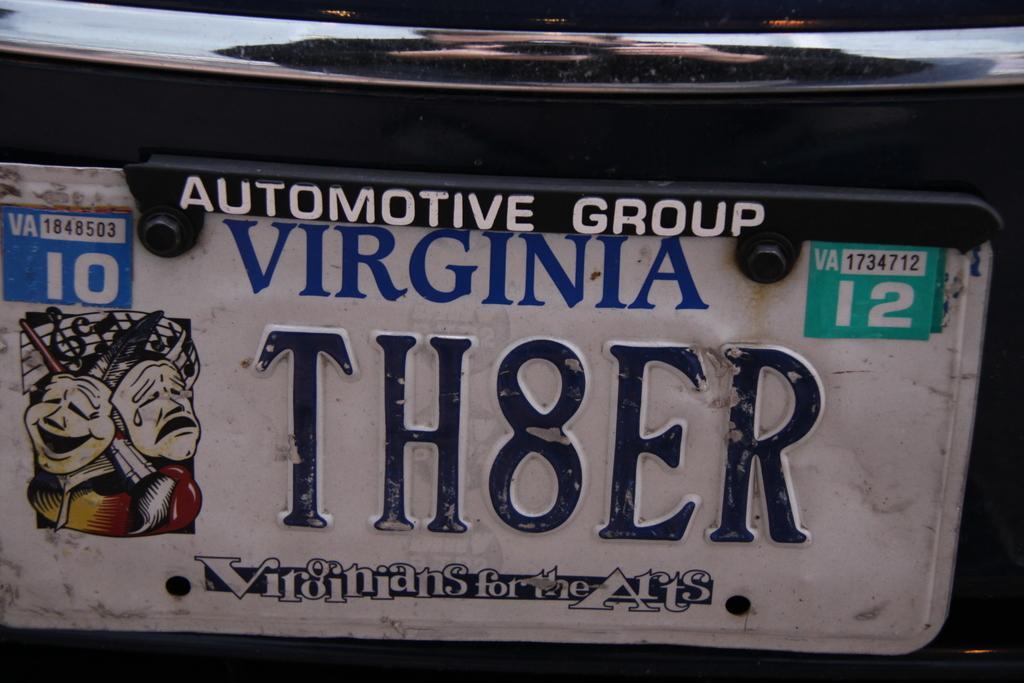Could you give a brief overview of what you see in this image? It is a number plate of a vehicle, the number is written in a combination of alphabets and numbers. 